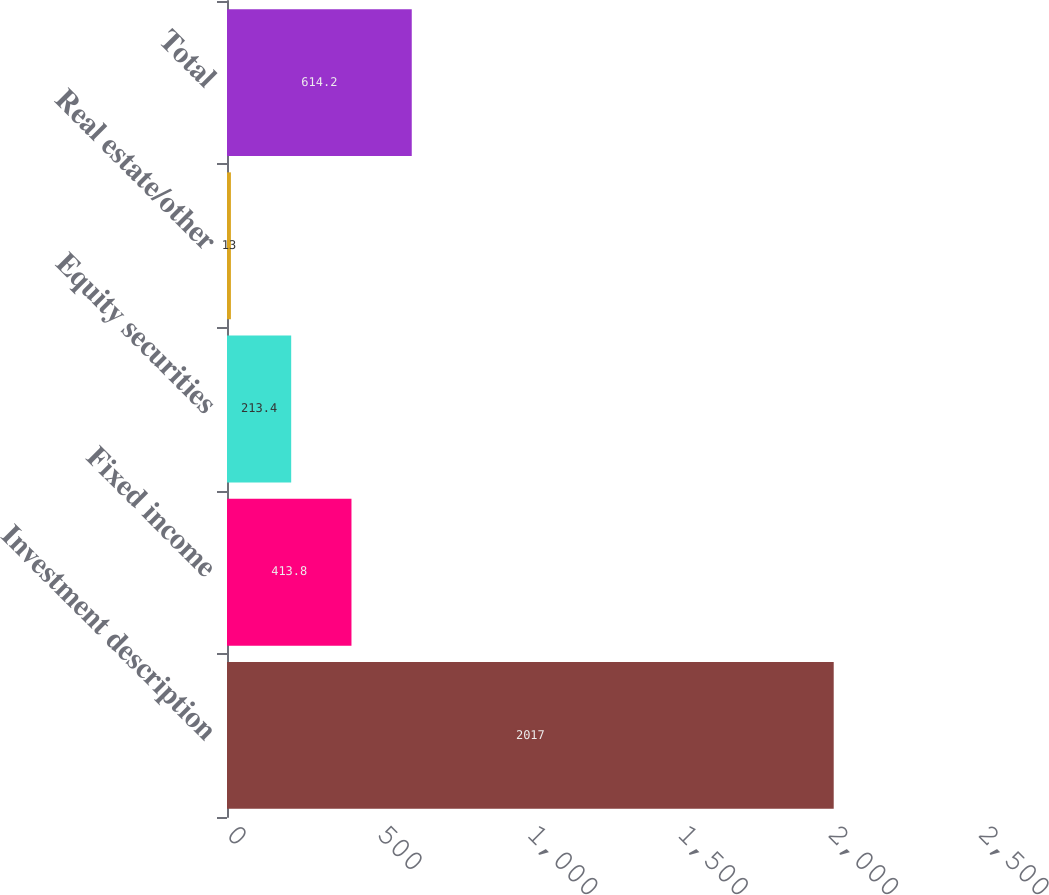Convert chart to OTSL. <chart><loc_0><loc_0><loc_500><loc_500><bar_chart><fcel>Investment description<fcel>Fixed income<fcel>Equity securities<fcel>Real estate/other<fcel>Total<nl><fcel>2017<fcel>413.8<fcel>213.4<fcel>13<fcel>614.2<nl></chart> 